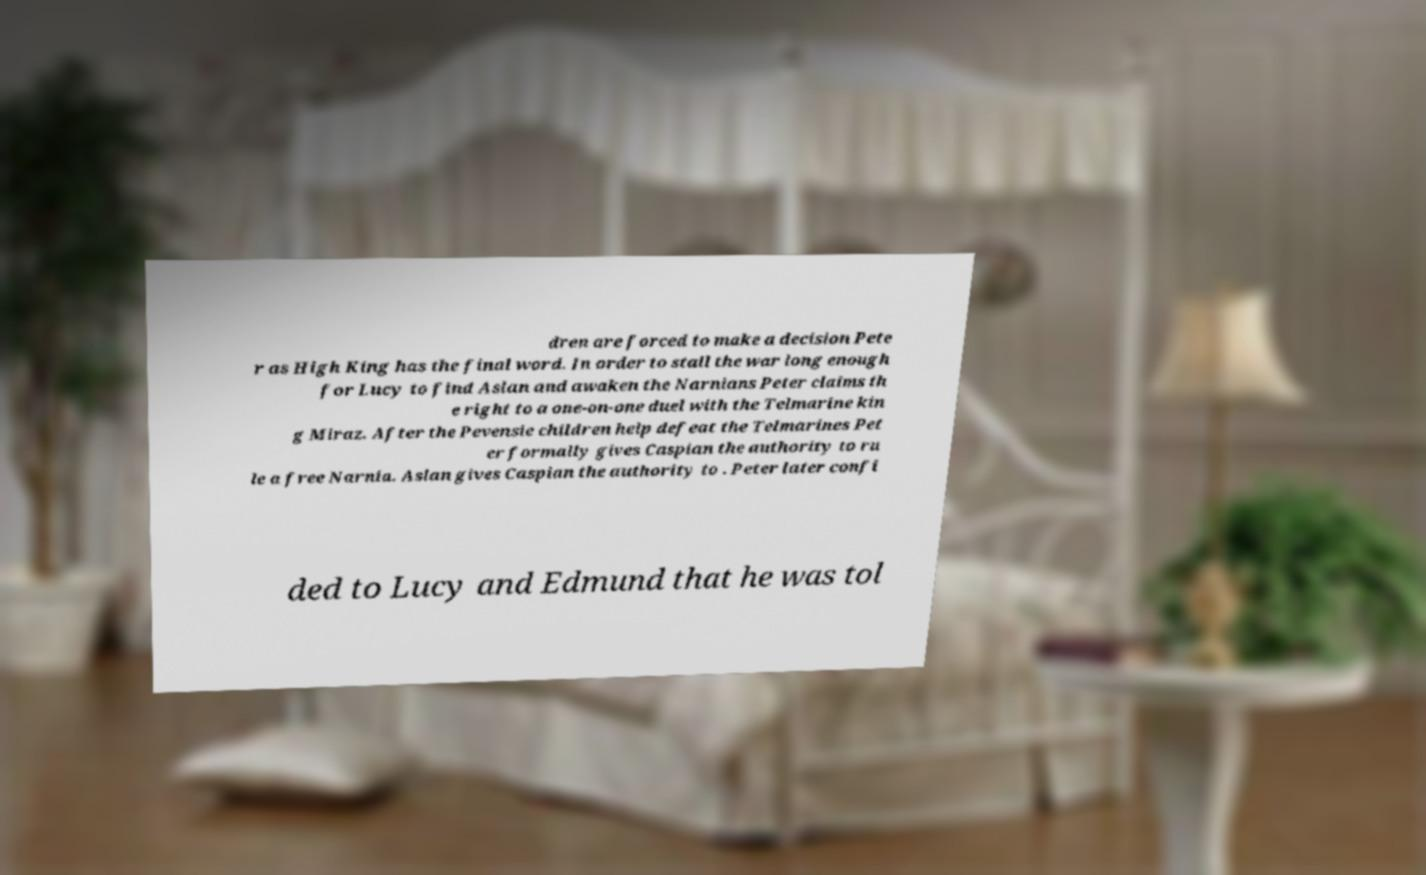Can you read and provide the text displayed in the image?This photo seems to have some interesting text. Can you extract and type it out for me? dren are forced to make a decision Pete r as High King has the final word. In order to stall the war long enough for Lucy to find Aslan and awaken the Narnians Peter claims th e right to a one-on-one duel with the Telmarine kin g Miraz. After the Pevensie children help defeat the Telmarines Pet er formally gives Caspian the authority to ru le a free Narnia. Aslan gives Caspian the authority to . Peter later confi ded to Lucy and Edmund that he was tol 